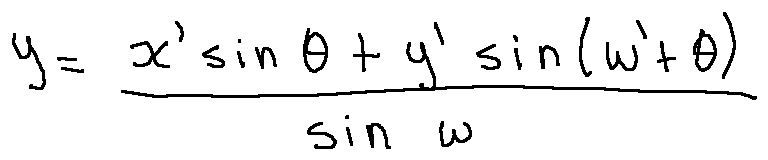<formula> <loc_0><loc_0><loc_500><loc_500>y = \frac { x \prime \sin \theta + y \prime \sin ( w \prime + \theta ) } { \sin w }</formula> 